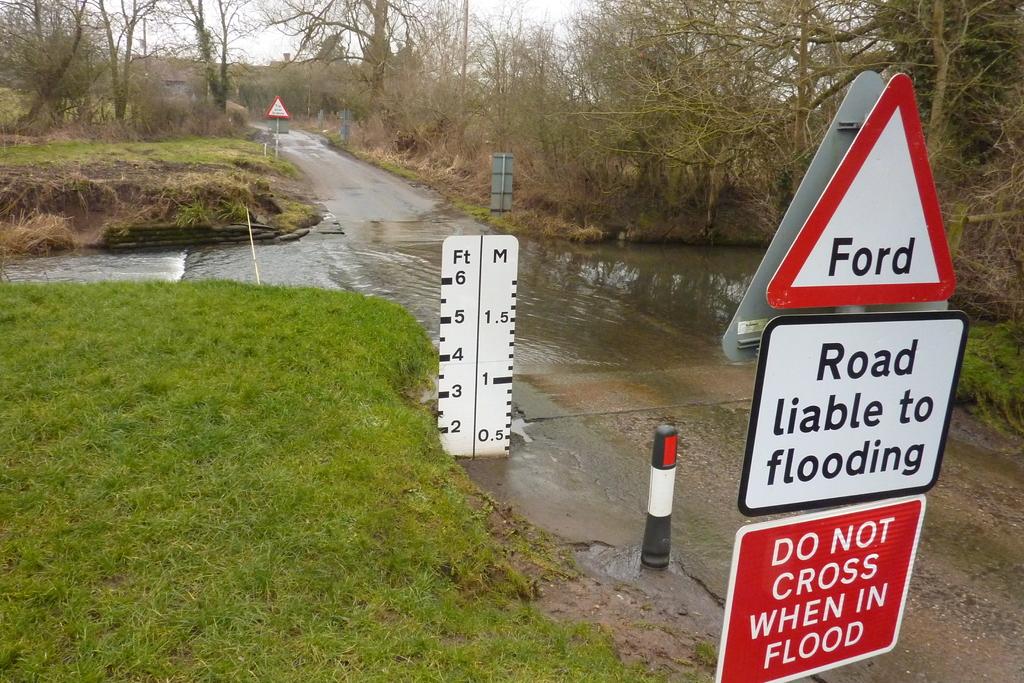What does the sign say not to do when the road is flooded?
Keep it short and to the point. Do not cross. What is the word in the triangle?
Your answer should be very brief. Ford. 